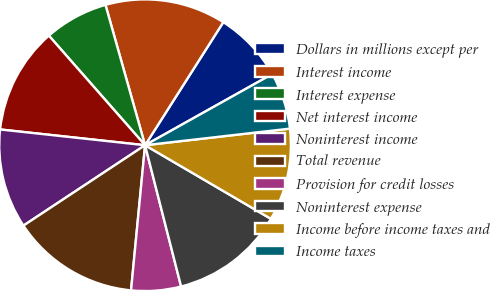Convert chart. <chart><loc_0><loc_0><loc_500><loc_500><pie_chart><fcel>Dollars in millions except per<fcel>Interest income<fcel>Interest expense<fcel>Net interest income<fcel>Noninterest income<fcel>Total revenue<fcel>Provision for credit losses<fcel>Noninterest expense<fcel>Income before income taxes and<fcel>Income taxes<nl><fcel>7.87%<fcel>13.39%<fcel>7.09%<fcel>11.81%<fcel>11.02%<fcel>14.17%<fcel>5.51%<fcel>12.6%<fcel>10.24%<fcel>6.3%<nl></chart> 